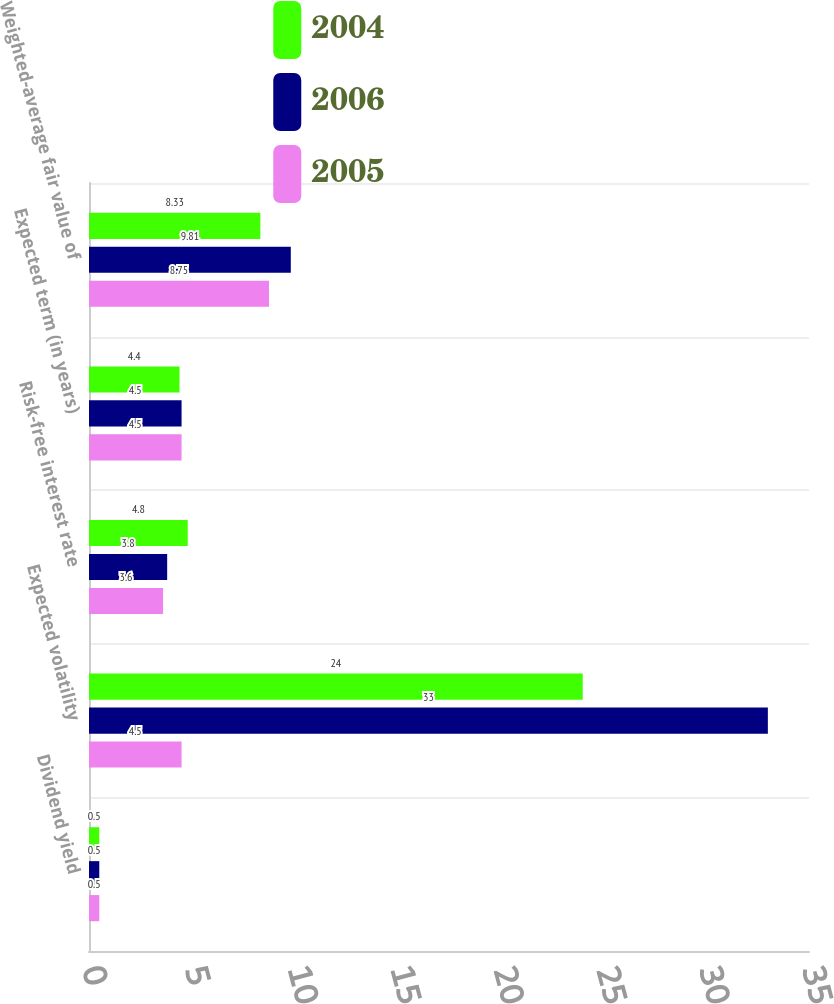Convert chart to OTSL. <chart><loc_0><loc_0><loc_500><loc_500><stacked_bar_chart><ecel><fcel>Dividend yield<fcel>Expected volatility<fcel>Risk-free interest rate<fcel>Expected term (in years)<fcel>Weighted-average fair value of<nl><fcel>2004<fcel>0.5<fcel>24<fcel>4.8<fcel>4.4<fcel>8.33<nl><fcel>2006<fcel>0.5<fcel>33<fcel>3.8<fcel>4.5<fcel>9.81<nl><fcel>2005<fcel>0.5<fcel>4.5<fcel>3.6<fcel>4.5<fcel>8.75<nl></chart> 